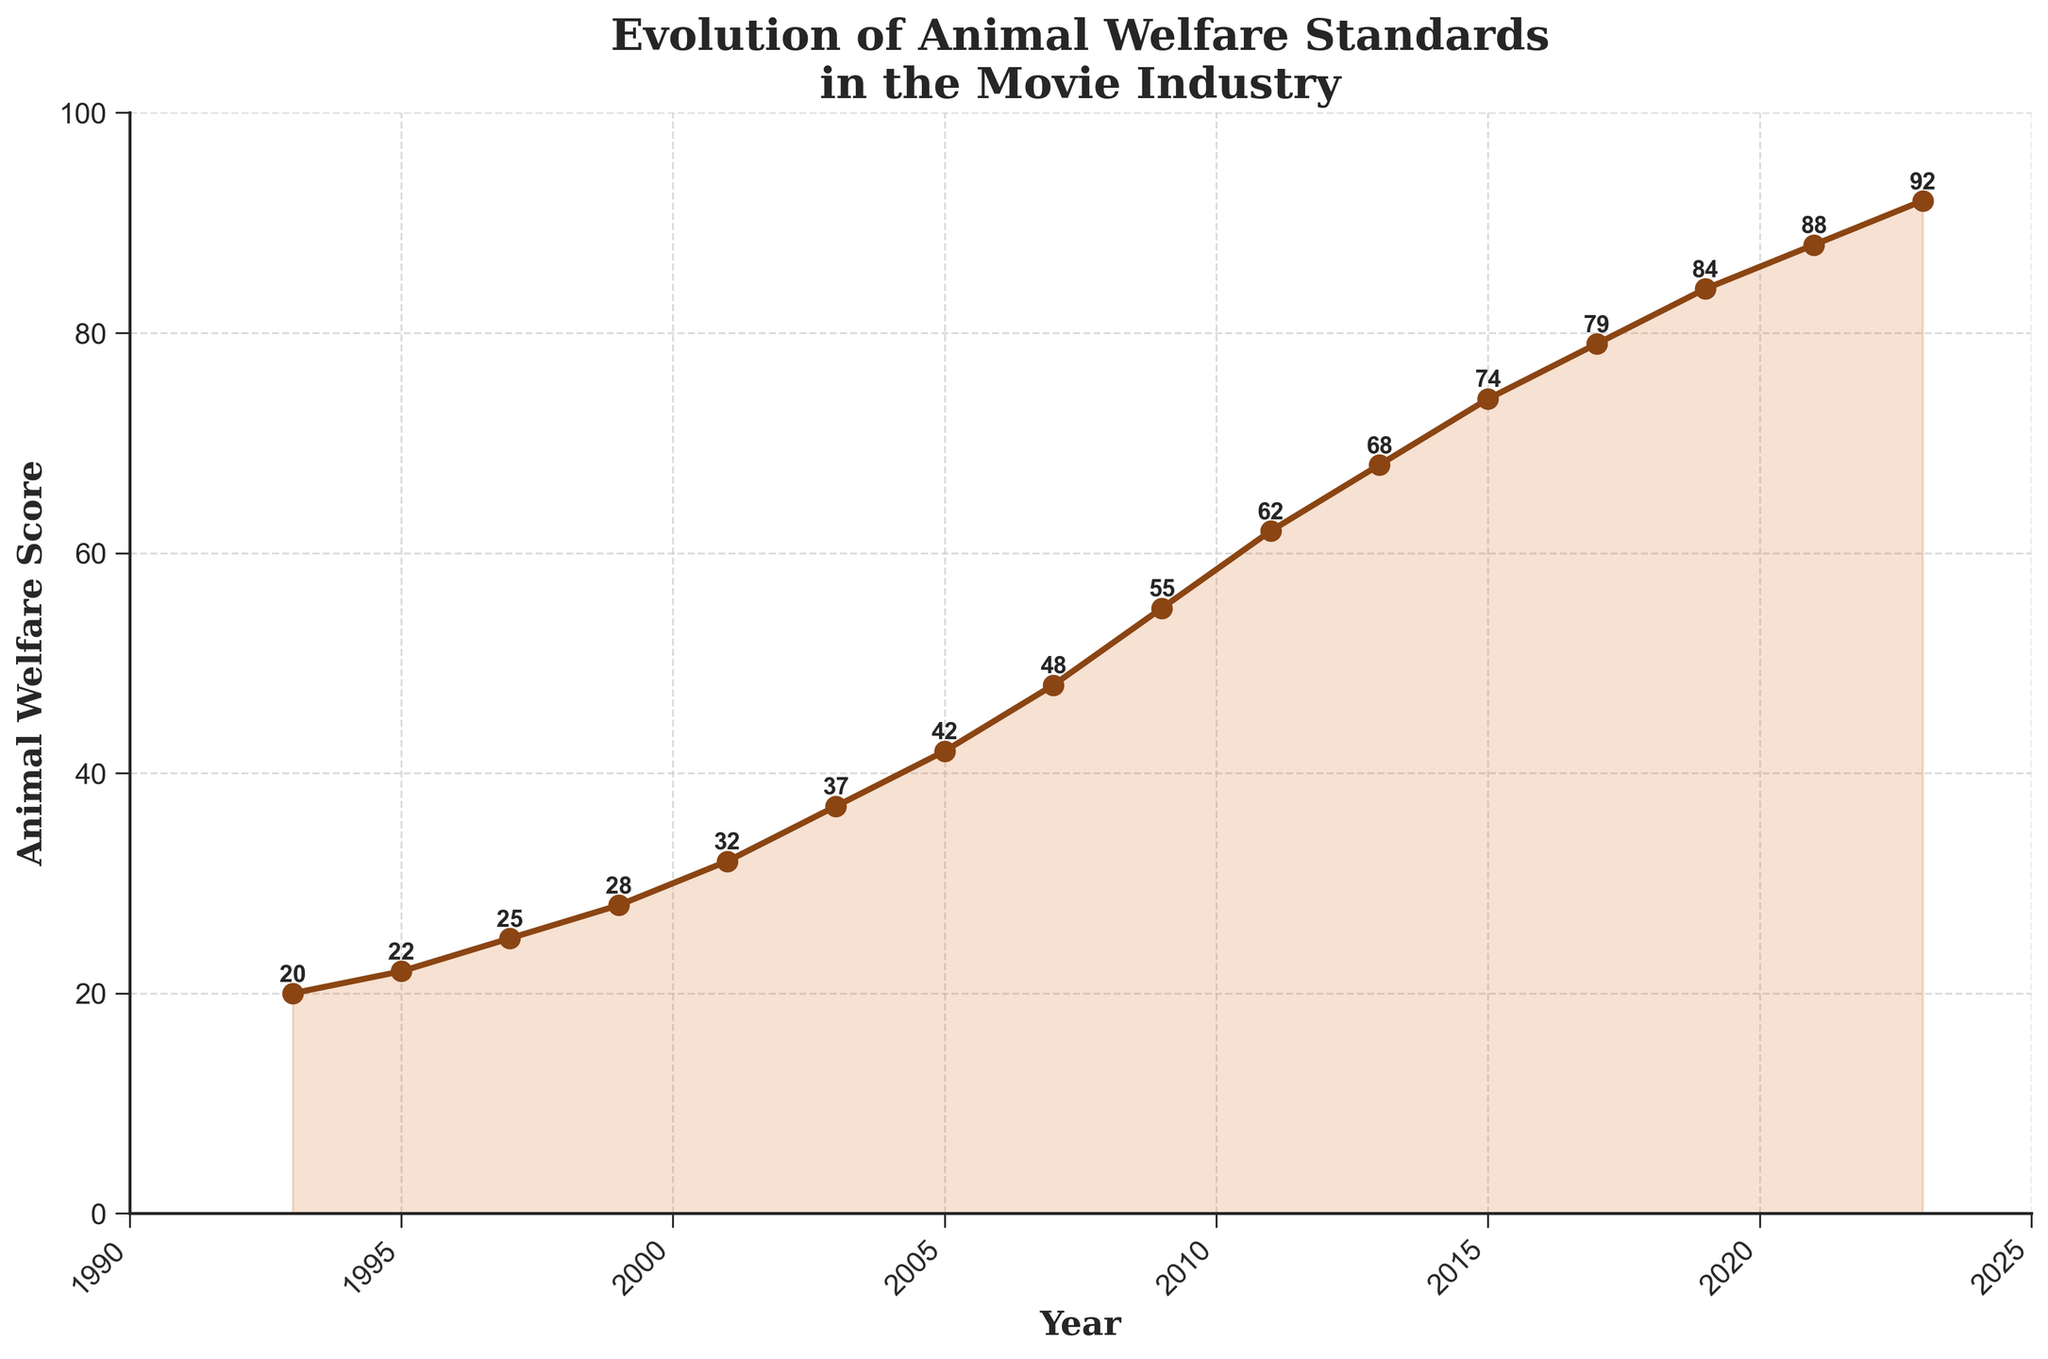Which year saw the most significant one-time increase in the Animal Welfare Score? To determine the most significant one-time increase, look at the differences between consecutive years’ scores. The difference is highest from 2007 (48) to 2009 (55), an increase of 7 points.
Answer: 2009 What is the average Animal Welfare Score from 1993 to 2023? Sum all the scores from 1993 (20) to 2023 (92) and divide by the number of years (16). The sum is 796, and the average is approximately 49.75.
Answer: 49.75 Which year had the smallest change in the Animal Welfare Score compared to the previous recorded year? Calculate the differences between consecutive years’ scores. The smallest change occurred between 2021 (88) and 2023 (92), an increase of just 4 points.
Answer: 2023 How many years did it take for the Animal Welfare Score to double from its 1993 value? Start with the 1993 value (20) and find the year in which the score is at least 40. By 2005, the score is 42, so it took 12 years.
Answer: 12 years What is the difference in the Animal Welfare Score between 1999 and 2003? The score in 1999 was 28, and in 2003 it was 37. The difference is 37 - 28, which is 9 points.
Answer: 9 points From 1993 to 2023, in which decade did the Animal Welfare Score improve the most? Compare the improvements over each decade. From 1993 to 2003, the score increased by 37 - 20 = 17 points. From 2003 to 2013, it increased by 68 - 37 = 31 points. From 2013 to 2023, it increased by 92 - 68 = 24 points. The greatest improvement occurred from 2003 to 2013.
Answer: 2003 to 2013 Looking at the plot, can you identify any years where standard improvements were particularly gradual or slow? Identify periods with smaller increments. The period from 2019 (84) to 2021 (88) shows a gradual improvement with only a 4-point increase.
Answer: 2019 to 2021 What was the median Animal Welfare Score over the recorded years? Arrange all scores in ascending order and find the middle value. With 16 data points, the median is the average of the 8th and 9th values: (48 + 55) / 2 = 51.5.
Answer: 51.5 Is there a visual trend of the scores accelerating over time, and if so, when does it appear to begin? By observing the slope of the line chart, the acceleration appears to begin around 2001, with increasing increments more apparent thereafter.
Answer: Around 2001 